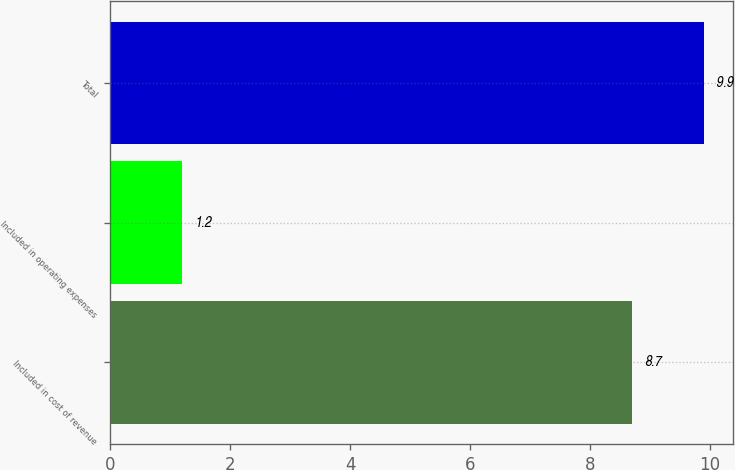<chart> <loc_0><loc_0><loc_500><loc_500><bar_chart><fcel>Included in cost of revenue<fcel>Included in operating expenses<fcel>Total<nl><fcel>8.7<fcel>1.2<fcel>9.9<nl></chart> 